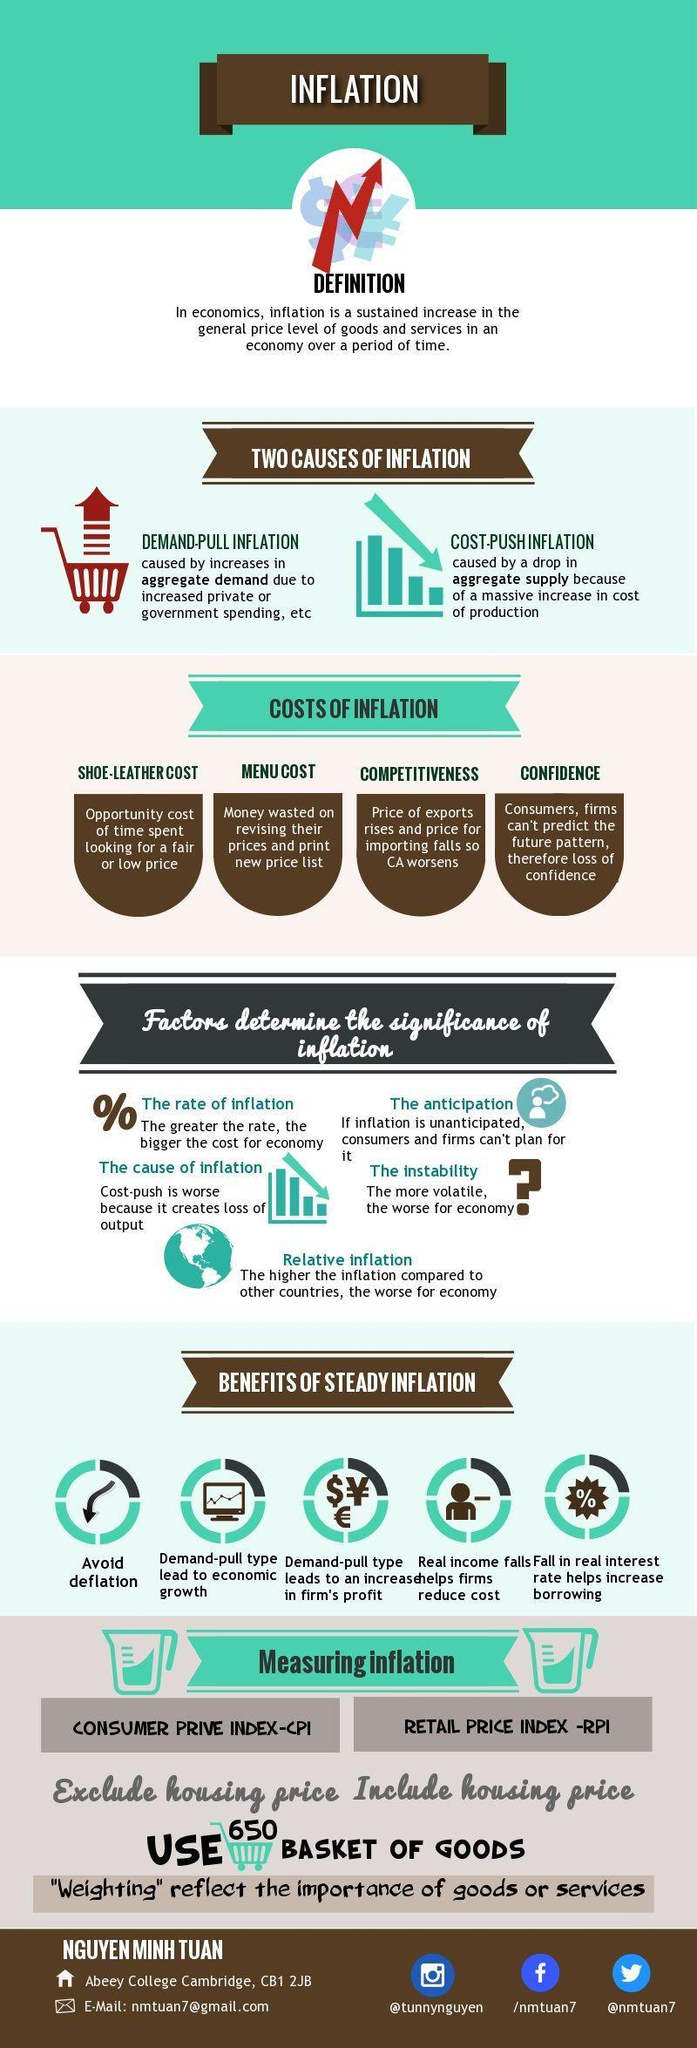What is the twitter handle of the student?
Answer the question with a short phrase. @nmtuan7 How many benefits of steady inflation are given? 5 How many costs of inflation are involved? 4 